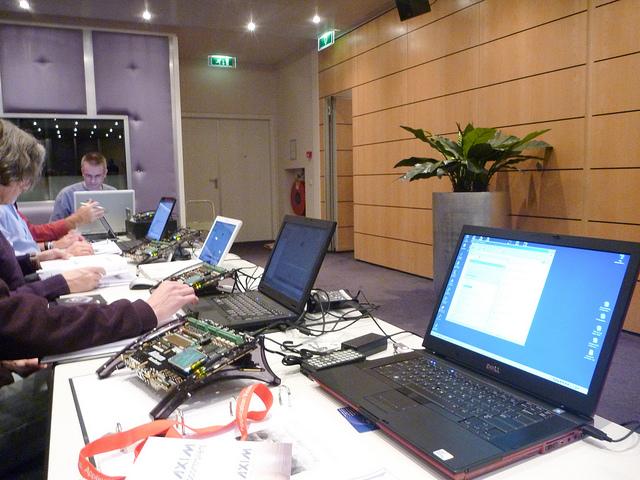What is the operating system shown on the computer screen?
Concise answer only. Windows. How many laptops are there?
Quick response, please. 5. Are these men at a computer store?
Short answer required. No. Are the laptops on?
Give a very brief answer. Yes. 